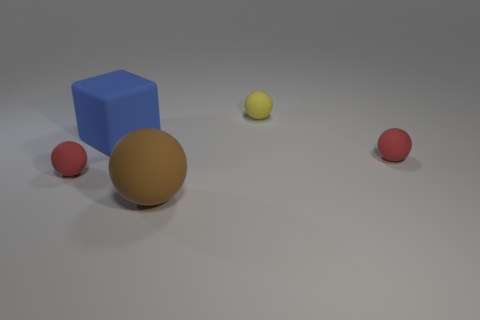Subtract all big rubber balls. How many balls are left? 3 Add 3 large blue spheres. How many objects exist? 8 Subtract all brown balls. How many balls are left? 3 Subtract all purple blocks. How many red balls are left? 2 Subtract all cubes. How many objects are left? 4 Add 4 small yellow spheres. How many small yellow spheres are left? 5 Add 2 blue metal balls. How many blue metal balls exist? 2 Subtract 2 red spheres. How many objects are left? 3 Subtract all yellow spheres. Subtract all red blocks. How many spheres are left? 3 Subtract all small rubber things. Subtract all small yellow cylinders. How many objects are left? 2 